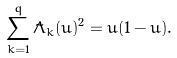<formula> <loc_0><loc_0><loc_500><loc_500>\sum _ { k = 1 } ^ { q } \tilde { \Lambda } _ { k } ( u ) ^ { 2 } = u ( 1 - u ) .</formula> 